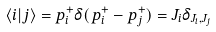Convert formula to latex. <formula><loc_0><loc_0><loc_500><loc_500>\langle i | j \rangle = p ^ { + } _ { i } \delta ( p ^ { + } _ { i } - p ^ { + } _ { j } ) = J _ { i } \delta _ { J _ { i } , J _ { j } }</formula> 